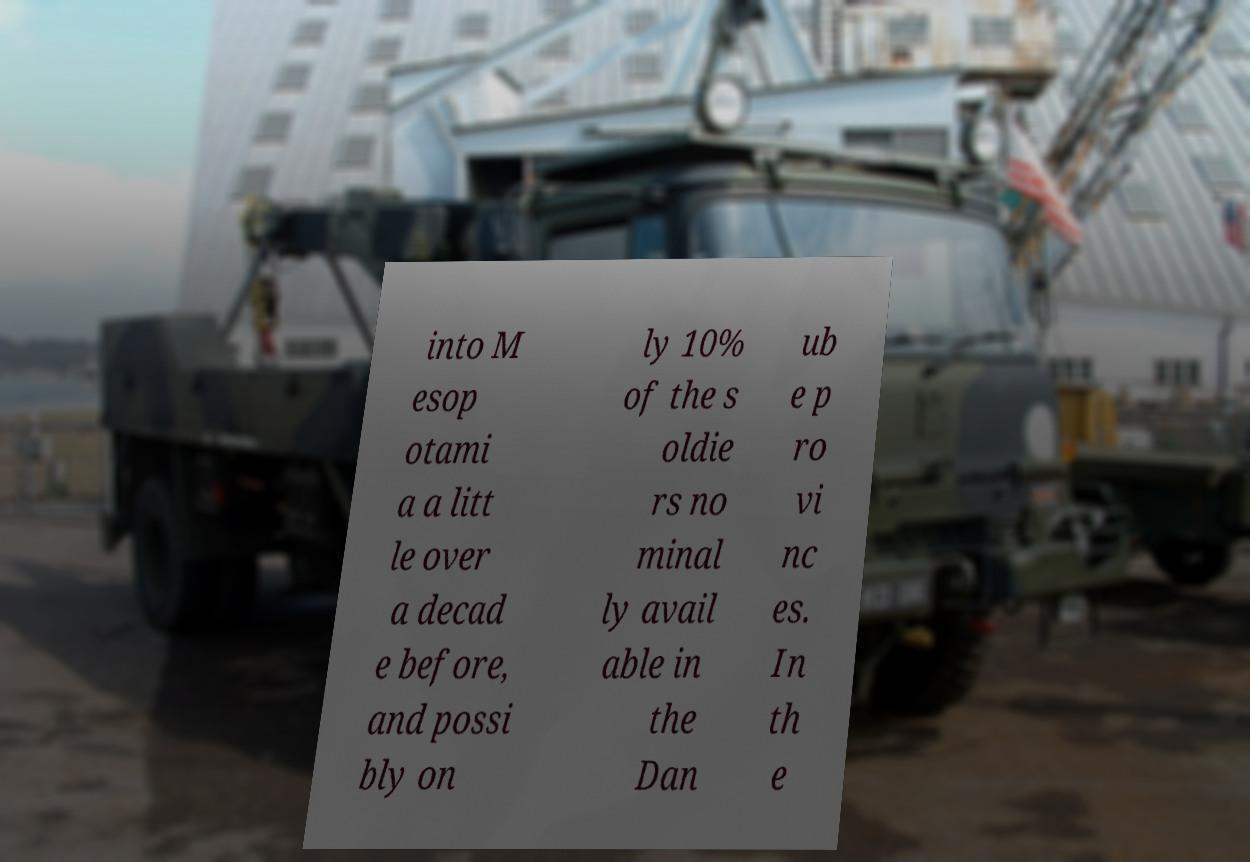Please read and relay the text visible in this image. What does it say? into M esop otami a a litt le over a decad e before, and possi bly on ly 10% of the s oldie rs no minal ly avail able in the Dan ub e p ro vi nc es. In th e 